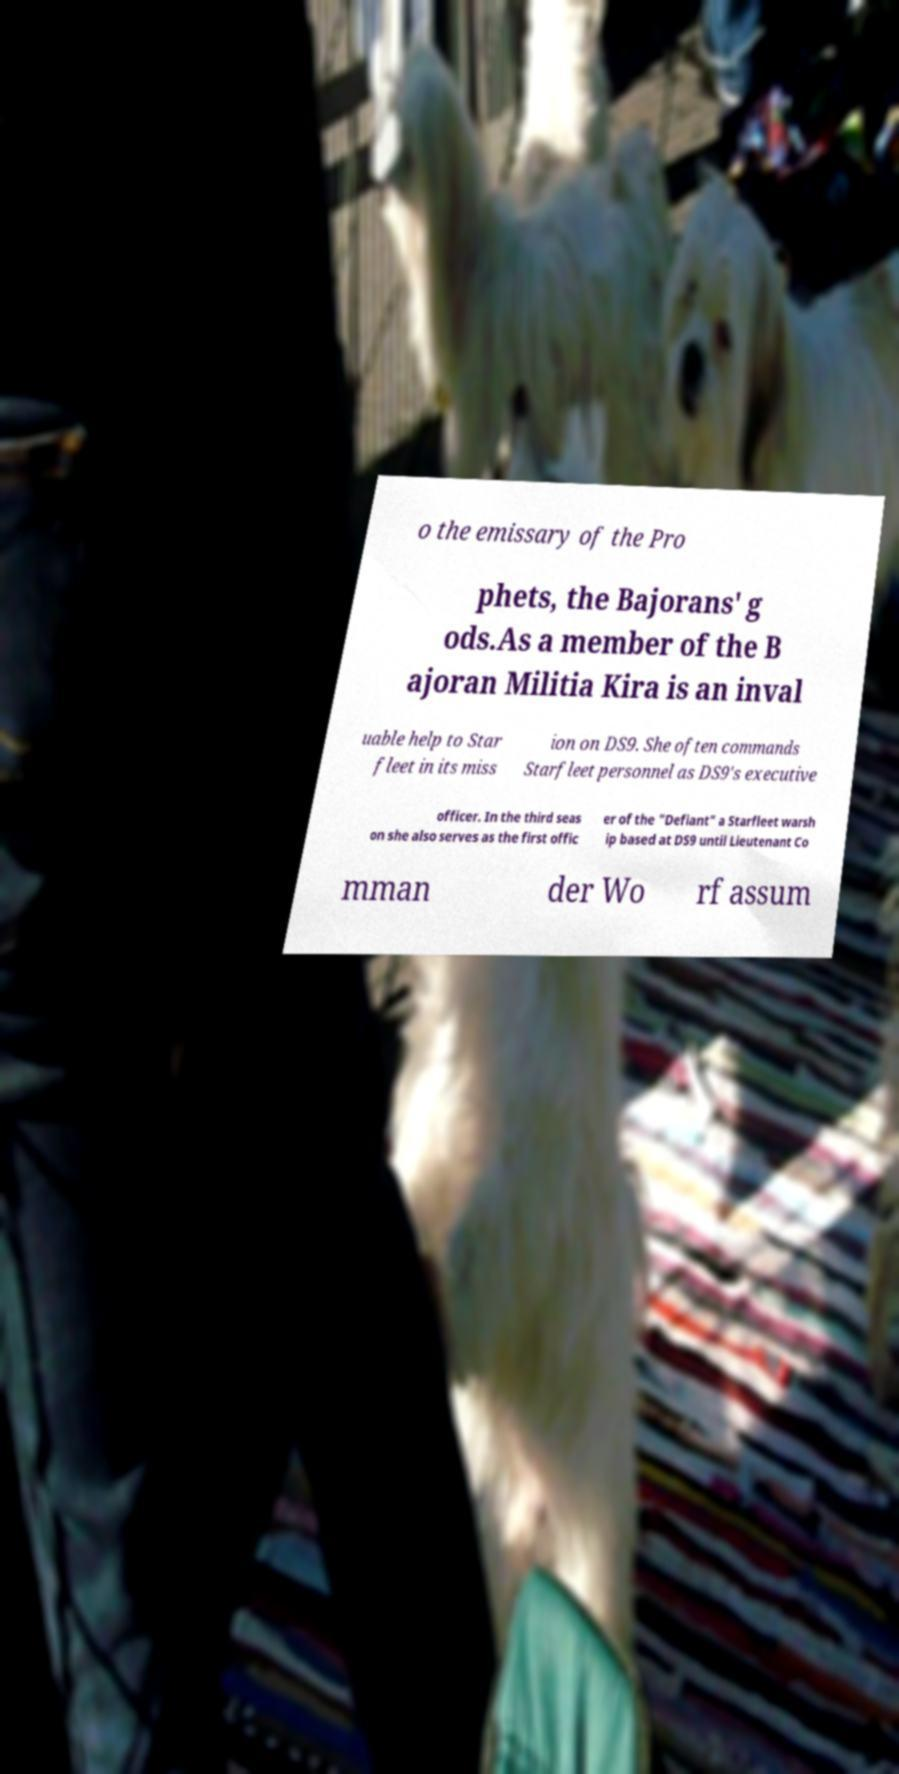I need the written content from this picture converted into text. Can you do that? o the emissary of the Pro phets, the Bajorans' g ods.As a member of the B ajoran Militia Kira is an inval uable help to Star fleet in its miss ion on DS9. She often commands Starfleet personnel as DS9's executive officer. In the third seas on she also serves as the first offic er of the "Defiant" a Starfleet warsh ip based at DS9 until Lieutenant Co mman der Wo rf assum 